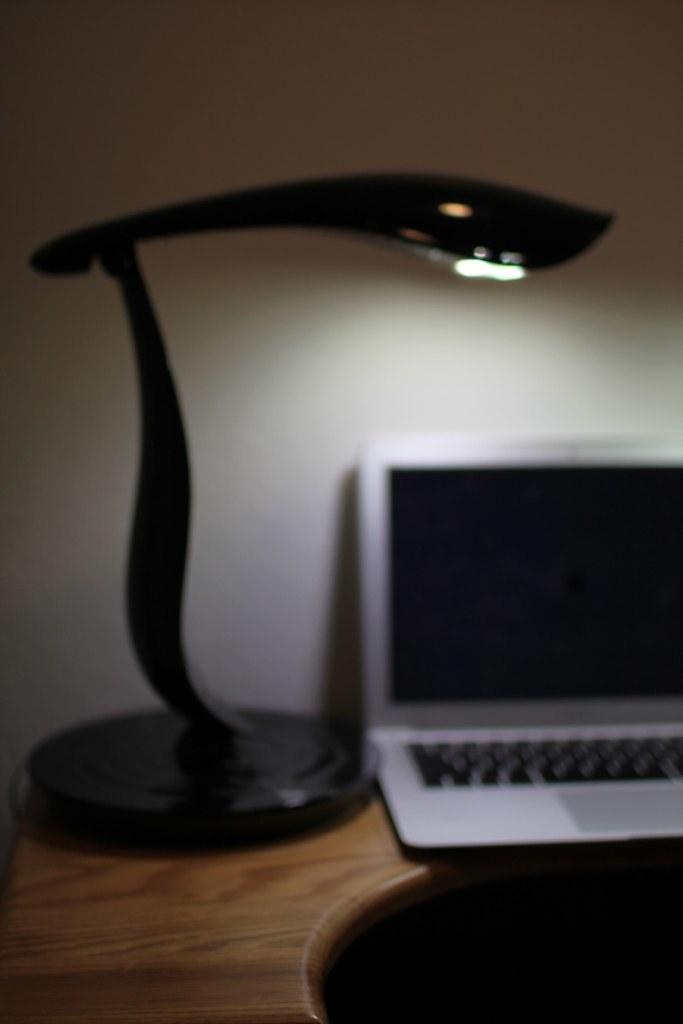In one or two sentences, can you explain what this image depicts? This is a picture taken in a room, this is a wooden table on the table there is a light and a laptop. Background of this laptop is a white wall. 